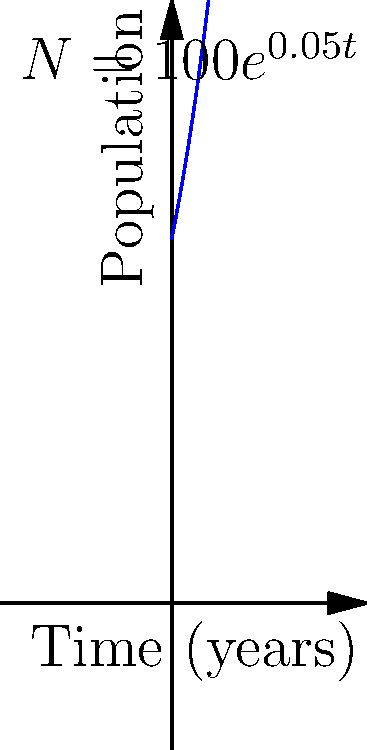As a conservationist studying the population growth of the endangered Swedish arctic fox, you've plotted their numbers using an exponential curve. The graph shows the population growth over time, following the equation $N = 100e^{0.05t}$, where $N$ is the population size and $t$ is time in years. What is the annual population growth rate for this species? To find the annual population growth rate, we need to follow these steps:

1) The general form of an exponential growth equation is:
   $N = N_0e^{rt}$
   where $N_0$ is the initial population, $r$ is the growth rate, and $t$ is time.

2) Comparing our equation $N = 100e^{0.05t}$ to the general form, we can see that:
   $N_0 = 100$
   $r = 0.05$

3) The value of $r$ (0.05) represents the continuous growth rate, but we need to convert this to an annual percentage growth rate.

4) To convert a continuous growth rate to an annual percentage rate, we use the formula:
   Annual Rate = $(e^r - 1) * 100\%$

5) Plugging in our $r$ value:
   Annual Rate = $(e^{0.05} - 1) * 100\%$
               = $(1.0513 - 1) * 100\%$
               = $0.0513 * 100\%$
               = $5.13\%$

Therefore, the annual population growth rate is approximately 5.13%.
Answer: $5.13\%$ 